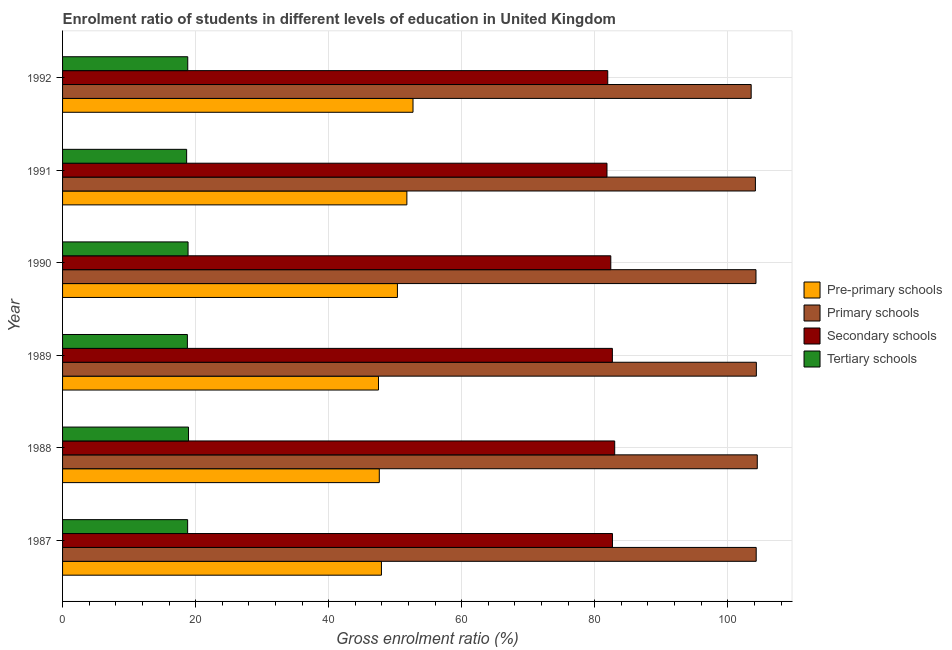How many different coloured bars are there?
Your answer should be compact. 4. How many groups of bars are there?
Your response must be concise. 6. Are the number of bars on each tick of the Y-axis equal?
Offer a terse response. Yes. How many bars are there on the 2nd tick from the top?
Provide a succinct answer. 4. How many bars are there on the 2nd tick from the bottom?
Your answer should be very brief. 4. What is the label of the 2nd group of bars from the top?
Your answer should be compact. 1991. In how many cases, is the number of bars for a given year not equal to the number of legend labels?
Keep it short and to the point. 0. What is the gross enrolment ratio in secondary schools in 1989?
Offer a very short reply. 82.65. Across all years, what is the maximum gross enrolment ratio in primary schools?
Offer a very short reply. 104.44. Across all years, what is the minimum gross enrolment ratio in pre-primary schools?
Make the answer very short. 47.49. In which year was the gross enrolment ratio in primary schools maximum?
Make the answer very short. 1988. In which year was the gross enrolment ratio in secondary schools minimum?
Make the answer very short. 1991. What is the total gross enrolment ratio in pre-primary schools in the graph?
Your response must be concise. 297.82. What is the difference between the gross enrolment ratio in tertiary schools in 1988 and that in 1989?
Provide a succinct answer. 0.17. What is the difference between the gross enrolment ratio in primary schools in 1987 and the gross enrolment ratio in tertiary schools in 1988?
Keep it short and to the point. 85.34. What is the average gross enrolment ratio in pre-primary schools per year?
Give a very brief answer. 49.64. In the year 1992, what is the difference between the gross enrolment ratio in pre-primary schools and gross enrolment ratio in tertiary schools?
Your answer should be compact. 33.86. In how many years, is the gross enrolment ratio in secondary schools greater than 96 %?
Keep it short and to the point. 0. What is the ratio of the gross enrolment ratio in tertiary schools in 1988 to that in 1990?
Keep it short and to the point. 1. Is the difference between the gross enrolment ratio in secondary schools in 1989 and 1990 greater than the difference between the gross enrolment ratio in tertiary schools in 1989 and 1990?
Your response must be concise. Yes. What is the difference between the highest and the second highest gross enrolment ratio in primary schools?
Give a very brief answer. 0.14. What is the difference between the highest and the lowest gross enrolment ratio in tertiary schools?
Offer a terse response. 0.28. In how many years, is the gross enrolment ratio in primary schools greater than the average gross enrolment ratio in primary schools taken over all years?
Offer a terse response. 5. Is the sum of the gross enrolment ratio in tertiary schools in 1989 and 1991 greater than the maximum gross enrolment ratio in pre-primary schools across all years?
Make the answer very short. No. What does the 4th bar from the top in 1991 represents?
Offer a very short reply. Pre-primary schools. What does the 1st bar from the bottom in 1992 represents?
Your answer should be very brief. Pre-primary schools. How many bars are there?
Ensure brevity in your answer.  24. Are all the bars in the graph horizontal?
Keep it short and to the point. Yes. What is the difference between two consecutive major ticks on the X-axis?
Provide a succinct answer. 20. What is the title of the graph?
Provide a succinct answer. Enrolment ratio of students in different levels of education in United Kingdom. Does "Source data assessment" appear as one of the legend labels in the graph?
Your answer should be compact. No. What is the label or title of the X-axis?
Offer a very short reply. Gross enrolment ratio (%). What is the Gross enrolment ratio (%) in Pre-primary schools in 1987?
Provide a succinct answer. 47.93. What is the Gross enrolment ratio (%) of Primary schools in 1987?
Your response must be concise. 104.27. What is the Gross enrolment ratio (%) of Secondary schools in 1987?
Your answer should be compact. 82.66. What is the Gross enrolment ratio (%) of Tertiary schools in 1987?
Offer a terse response. 18.8. What is the Gross enrolment ratio (%) of Pre-primary schools in 1988?
Keep it short and to the point. 47.61. What is the Gross enrolment ratio (%) of Primary schools in 1988?
Offer a very short reply. 104.44. What is the Gross enrolment ratio (%) of Secondary schools in 1988?
Your answer should be compact. 83. What is the Gross enrolment ratio (%) of Tertiary schools in 1988?
Offer a very short reply. 18.93. What is the Gross enrolment ratio (%) in Pre-primary schools in 1989?
Give a very brief answer. 47.49. What is the Gross enrolment ratio (%) of Primary schools in 1989?
Give a very brief answer. 104.29. What is the Gross enrolment ratio (%) of Secondary schools in 1989?
Offer a terse response. 82.65. What is the Gross enrolment ratio (%) in Tertiary schools in 1989?
Offer a very short reply. 18.76. What is the Gross enrolment ratio (%) of Pre-primary schools in 1990?
Offer a very short reply. 50.34. What is the Gross enrolment ratio (%) in Primary schools in 1990?
Make the answer very short. 104.24. What is the Gross enrolment ratio (%) of Secondary schools in 1990?
Provide a short and direct response. 82.41. What is the Gross enrolment ratio (%) of Tertiary schools in 1990?
Your answer should be very brief. 18.87. What is the Gross enrolment ratio (%) of Pre-primary schools in 1991?
Keep it short and to the point. 51.76. What is the Gross enrolment ratio (%) of Primary schools in 1991?
Offer a very short reply. 104.15. What is the Gross enrolment ratio (%) of Secondary schools in 1991?
Your answer should be compact. 81.84. What is the Gross enrolment ratio (%) in Tertiary schools in 1991?
Your response must be concise. 18.65. What is the Gross enrolment ratio (%) of Pre-primary schools in 1992?
Provide a short and direct response. 52.68. What is the Gross enrolment ratio (%) of Primary schools in 1992?
Provide a short and direct response. 103.52. What is the Gross enrolment ratio (%) in Secondary schools in 1992?
Your answer should be very brief. 81.96. What is the Gross enrolment ratio (%) of Tertiary schools in 1992?
Make the answer very short. 18.82. Across all years, what is the maximum Gross enrolment ratio (%) in Pre-primary schools?
Keep it short and to the point. 52.68. Across all years, what is the maximum Gross enrolment ratio (%) in Primary schools?
Offer a very short reply. 104.44. Across all years, what is the maximum Gross enrolment ratio (%) of Secondary schools?
Provide a short and direct response. 83. Across all years, what is the maximum Gross enrolment ratio (%) of Tertiary schools?
Your response must be concise. 18.93. Across all years, what is the minimum Gross enrolment ratio (%) in Pre-primary schools?
Keep it short and to the point. 47.49. Across all years, what is the minimum Gross enrolment ratio (%) in Primary schools?
Make the answer very short. 103.52. Across all years, what is the minimum Gross enrolment ratio (%) of Secondary schools?
Offer a terse response. 81.84. Across all years, what is the minimum Gross enrolment ratio (%) of Tertiary schools?
Keep it short and to the point. 18.65. What is the total Gross enrolment ratio (%) in Pre-primary schools in the graph?
Offer a terse response. 297.82. What is the total Gross enrolment ratio (%) in Primary schools in the graph?
Ensure brevity in your answer.  624.91. What is the total Gross enrolment ratio (%) of Secondary schools in the graph?
Your response must be concise. 494.53. What is the total Gross enrolment ratio (%) of Tertiary schools in the graph?
Ensure brevity in your answer.  112.84. What is the difference between the Gross enrolment ratio (%) of Pre-primary schools in 1987 and that in 1988?
Offer a very short reply. 0.32. What is the difference between the Gross enrolment ratio (%) in Primary schools in 1987 and that in 1988?
Provide a succinct answer. -0.16. What is the difference between the Gross enrolment ratio (%) of Secondary schools in 1987 and that in 1988?
Make the answer very short. -0.34. What is the difference between the Gross enrolment ratio (%) in Tertiary schools in 1987 and that in 1988?
Provide a succinct answer. -0.13. What is the difference between the Gross enrolment ratio (%) in Pre-primary schools in 1987 and that in 1989?
Provide a short and direct response. 0.44. What is the difference between the Gross enrolment ratio (%) of Primary schools in 1987 and that in 1989?
Provide a succinct answer. -0.02. What is the difference between the Gross enrolment ratio (%) in Secondary schools in 1987 and that in 1989?
Your answer should be very brief. 0.01. What is the difference between the Gross enrolment ratio (%) of Tertiary schools in 1987 and that in 1989?
Keep it short and to the point. 0.04. What is the difference between the Gross enrolment ratio (%) of Pre-primary schools in 1987 and that in 1990?
Your response must be concise. -2.4. What is the difference between the Gross enrolment ratio (%) in Primary schools in 1987 and that in 1990?
Provide a succinct answer. 0.03. What is the difference between the Gross enrolment ratio (%) in Secondary schools in 1987 and that in 1990?
Your answer should be very brief. 0.25. What is the difference between the Gross enrolment ratio (%) in Tertiary schools in 1987 and that in 1990?
Provide a succinct answer. -0.06. What is the difference between the Gross enrolment ratio (%) of Pre-primary schools in 1987 and that in 1991?
Your answer should be very brief. -3.82. What is the difference between the Gross enrolment ratio (%) in Primary schools in 1987 and that in 1991?
Your answer should be very brief. 0.12. What is the difference between the Gross enrolment ratio (%) in Secondary schools in 1987 and that in 1991?
Keep it short and to the point. 0.82. What is the difference between the Gross enrolment ratio (%) of Tertiary schools in 1987 and that in 1991?
Make the answer very short. 0.15. What is the difference between the Gross enrolment ratio (%) of Pre-primary schools in 1987 and that in 1992?
Your answer should be very brief. -4.75. What is the difference between the Gross enrolment ratio (%) in Primary schools in 1987 and that in 1992?
Your response must be concise. 0.76. What is the difference between the Gross enrolment ratio (%) of Secondary schools in 1987 and that in 1992?
Keep it short and to the point. 0.71. What is the difference between the Gross enrolment ratio (%) in Tertiary schools in 1987 and that in 1992?
Offer a terse response. -0.02. What is the difference between the Gross enrolment ratio (%) of Pre-primary schools in 1988 and that in 1989?
Ensure brevity in your answer.  0.12. What is the difference between the Gross enrolment ratio (%) of Primary schools in 1988 and that in 1989?
Offer a very short reply. 0.14. What is the difference between the Gross enrolment ratio (%) in Secondary schools in 1988 and that in 1989?
Ensure brevity in your answer.  0.35. What is the difference between the Gross enrolment ratio (%) in Tertiary schools in 1988 and that in 1989?
Your answer should be compact. 0.17. What is the difference between the Gross enrolment ratio (%) in Pre-primary schools in 1988 and that in 1990?
Offer a very short reply. -2.73. What is the difference between the Gross enrolment ratio (%) in Primary schools in 1988 and that in 1990?
Your answer should be compact. 0.2. What is the difference between the Gross enrolment ratio (%) of Secondary schools in 1988 and that in 1990?
Provide a succinct answer. 0.59. What is the difference between the Gross enrolment ratio (%) of Tertiary schools in 1988 and that in 1990?
Your answer should be very brief. 0.07. What is the difference between the Gross enrolment ratio (%) of Pre-primary schools in 1988 and that in 1991?
Give a very brief answer. -4.14. What is the difference between the Gross enrolment ratio (%) of Primary schools in 1988 and that in 1991?
Ensure brevity in your answer.  0.28. What is the difference between the Gross enrolment ratio (%) of Secondary schools in 1988 and that in 1991?
Ensure brevity in your answer.  1.16. What is the difference between the Gross enrolment ratio (%) of Tertiary schools in 1988 and that in 1991?
Your answer should be very brief. 0.28. What is the difference between the Gross enrolment ratio (%) of Pre-primary schools in 1988 and that in 1992?
Provide a succinct answer. -5.07. What is the difference between the Gross enrolment ratio (%) of Primary schools in 1988 and that in 1992?
Offer a terse response. 0.92. What is the difference between the Gross enrolment ratio (%) in Secondary schools in 1988 and that in 1992?
Ensure brevity in your answer.  1.05. What is the difference between the Gross enrolment ratio (%) of Tertiary schools in 1988 and that in 1992?
Provide a short and direct response. 0.12. What is the difference between the Gross enrolment ratio (%) in Pre-primary schools in 1989 and that in 1990?
Your response must be concise. -2.84. What is the difference between the Gross enrolment ratio (%) in Primary schools in 1989 and that in 1990?
Your response must be concise. 0.06. What is the difference between the Gross enrolment ratio (%) in Secondary schools in 1989 and that in 1990?
Your response must be concise. 0.24. What is the difference between the Gross enrolment ratio (%) in Tertiary schools in 1989 and that in 1990?
Offer a very short reply. -0.1. What is the difference between the Gross enrolment ratio (%) in Pre-primary schools in 1989 and that in 1991?
Ensure brevity in your answer.  -4.26. What is the difference between the Gross enrolment ratio (%) in Primary schools in 1989 and that in 1991?
Provide a short and direct response. 0.14. What is the difference between the Gross enrolment ratio (%) of Secondary schools in 1989 and that in 1991?
Provide a short and direct response. 0.81. What is the difference between the Gross enrolment ratio (%) of Tertiary schools in 1989 and that in 1991?
Your answer should be compact. 0.11. What is the difference between the Gross enrolment ratio (%) in Pre-primary schools in 1989 and that in 1992?
Make the answer very short. -5.19. What is the difference between the Gross enrolment ratio (%) of Primary schools in 1989 and that in 1992?
Offer a very short reply. 0.78. What is the difference between the Gross enrolment ratio (%) in Secondary schools in 1989 and that in 1992?
Offer a terse response. 0.7. What is the difference between the Gross enrolment ratio (%) in Tertiary schools in 1989 and that in 1992?
Ensure brevity in your answer.  -0.05. What is the difference between the Gross enrolment ratio (%) of Pre-primary schools in 1990 and that in 1991?
Your answer should be very brief. -1.42. What is the difference between the Gross enrolment ratio (%) of Primary schools in 1990 and that in 1991?
Ensure brevity in your answer.  0.09. What is the difference between the Gross enrolment ratio (%) in Secondary schools in 1990 and that in 1991?
Keep it short and to the point. 0.57. What is the difference between the Gross enrolment ratio (%) in Tertiary schools in 1990 and that in 1991?
Offer a terse response. 0.21. What is the difference between the Gross enrolment ratio (%) in Pre-primary schools in 1990 and that in 1992?
Offer a terse response. -2.34. What is the difference between the Gross enrolment ratio (%) of Primary schools in 1990 and that in 1992?
Your response must be concise. 0.72. What is the difference between the Gross enrolment ratio (%) of Secondary schools in 1990 and that in 1992?
Your response must be concise. 0.46. What is the difference between the Gross enrolment ratio (%) in Tertiary schools in 1990 and that in 1992?
Your answer should be compact. 0.05. What is the difference between the Gross enrolment ratio (%) of Pre-primary schools in 1991 and that in 1992?
Offer a very short reply. -0.92. What is the difference between the Gross enrolment ratio (%) in Primary schools in 1991 and that in 1992?
Keep it short and to the point. 0.64. What is the difference between the Gross enrolment ratio (%) of Secondary schools in 1991 and that in 1992?
Give a very brief answer. -0.11. What is the difference between the Gross enrolment ratio (%) in Tertiary schools in 1991 and that in 1992?
Your response must be concise. -0.17. What is the difference between the Gross enrolment ratio (%) of Pre-primary schools in 1987 and the Gross enrolment ratio (%) of Primary schools in 1988?
Provide a short and direct response. -56.5. What is the difference between the Gross enrolment ratio (%) in Pre-primary schools in 1987 and the Gross enrolment ratio (%) in Secondary schools in 1988?
Offer a very short reply. -35.07. What is the difference between the Gross enrolment ratio (%) in Pre-primary schools in 1987 and the Gross enrolment ratio (%) in Tertiary schools in 1988?
Provide a succinct answer. 29. What is the difference between the Gross enrolment ratio (%) of Primary schools in 1987 and the Gross enrolment ratio (%) of Secondary schools in 1988?
Keep it short and to the point. 21.27. What is the difference between the Gross enrolment ratio (%) in Primary schools in 1987 and the Gross enrolment ratio (%) in Tertiary schools in 1988?
Provide a succinct answer. 85.34. What is the difference between the Gross enrolment ratio (%) of Secondary schools in 1987 and the Gross enrolment ratio (%) of Tertiary schools in 1988?
Your response must be concise. 63.73. What is the difference between the Gross enrolment ratio (%) of Pre-primary schools in 1987 and the Gross enrolment ratio (%) of Primary schools in 1989?
Your answer should be very brief. -56.36. What is the difference between the Gross enrolment ratio (%) in Pre-primary schools in 1987 and the Gross enrolment ratio (%) in Secondary schools in 1989?
Provide a succinct answer. -34.72. What is the difference between the Gross enrolment ratio (%) of Pre-primary schools in 1987 and the Gross enrolment ratio (%) of Tertiary schools in 1989?
Provide a short and direct response. 29.17. What is the difference between the Gross enrolment ratio (%) in Primary schools in 1987 and the Gross enrolment ratio (%) in Secondary schools in 1989?
Your answer should be compact. 21.62. What is the difference between the Gross enrolment ratio (%) of Primary schools in 1987 and the Gross enrolment ratio (%) of Tertiary schools in 1989?
Make the answer very short. 85.51. What is the difference between the Gross enrolment ratio (%) in Secondary schools in 1987 and the Gross enrolment ratio (%) in Tertiary schools in 1989?
Offer a terse response. 63.9. What is the difference between the Gross enrolment ratio (%) of Pre-primary schools in 1987 and the Gross enrolment ratio (%) of Primary schools in 1990?
Offer a terse response. -56.3. What is the difference between the Gross enrolment ratio (%) of Pre-primary schools in 1987 and the Gross enrolment ratio (%) of Secondary schools in 1990?
Keep it short and to the point. -34.48. What is the difference between the Gross enrolment ratio (%) in Pre-primary schools in 1987 and the Gross enrolment ratio (%) in Tertiary schools in 1990?
Provide a short and direct response. 29.07. What is the difference between the Gross enrolment ratio (%) of Primary schools in 1987 and the Gross enrolment ratio (%) of Secondary schools in 1990?
Offer a terse response. 21.86. What is the difference between the Gross enrolment ratio (%) of Primary schools in 1987 and the Gross enrolment ratio (%) of Tertiary schools in 1990?
Keep it short and to the point. 85.41. What is the difference between the Gross enrolment ratio (%) in Secondary schools in 1987 and the Gross enrolment ratio (%) in Tertiary schools in 1990?
Offer a terse response. 63.8. What is the difference between the Gross enrolment ratio (%) in Pre-primary schools in 1987 and the Gross enrolment ratio (%) in Primary schools in 1991?
Offer a terse response. -56.22. What is the difference between the Gross enrolment ratio (%) in Pre-primary schools in 1987 and the Gross enrolment ratio (%) in Secondary schools in 1991?
Your response must be concise. -33.91. What is the difference between the Gross enrolment ratio (%) of Pre-primary schools in 1987 and the Gross enrolment ratio (%) of Tertiary schools in 1991?
Make the answer very short. 29.28. What is the difference between the Gross enrolment ratio (%) of Primary schools in 1987 and the Gross enrolment ratio (%) of Secondary schools in 1991?
Provide a short and direct response. 22.43. What is the difference between the Gross enrolment ratio (%) in Primary schools in 1987 and the Gross enrolment ratio (%) in Tertiary schools in 1991?
Give a very brief answer. 85.62. What is the difference between the Gross enrolment ratio (%) in Secondary schools in 1987 and the Gross enrolment ratio (%) in Tertiary schools in 1991?
Offer a very short reply. 64.01. What is the difference between the Gross enrolment ratio (%) of Pre-primary schools in 1987 and the Gross enrolment ratio (%) of Primary schools in 1992?
Ensure brevity in your answer.  -55.58. What is the difference between the Gross enrolment ratio (%) of Pre-primary schools in 1987 and the Gross enrolment ratio (%) of Secondary schools in 1992?
Make the answer very short. -34.02. What is the difference between the Gross enrolment ratio (%) in Pre-primary schools in 1987 and the Gross enrolment ratio (%) in Tertiary schools in 1992?
Keep it short and to the point. 29.12. What is the difference between the Gross enrolment ratio (%) of Primary schools in 1987 and the Gross enrolment ratio (%) of Secondary schools in 1992?
Provide a short and direct response. 22.32. What is the difference between the Gross enrolment ratio (%) of Primary schools in 1987 and the Gross enrolment ratio (%) of Tertiary schools in 1992?
Keep it short and to the point. 85.45. What is the difference between the Gross enrolment ratio (%) of Secondary schools in 1987 and the Gross enrolment ratio (%) of Tertiary schools in 1992?
Your answer should be compact. 63.85. What is the difference between the Gross enrolment ratio (%) in Pre-primary schools in 1988 and the Gross enrolment ratio (%) in Primary schools in 1989?
Ensure brevity in your answer.  -56.68. What is the difference between the Gross enrolment ratio (%) in Pre-primary schools in 1988 and the Gross enrolment ratio (%) in Secondary schools in 1989?
Offer a very short reply. -35.04. What is the difference between the Gross enrolment ratio (%) in Pre-primary schools in 1988 and the Gross enrolment ratio (%) in Tertiary schools in 1989?
Offer a very short reply. 28.85. What is the difference between the Gross enrolment ratio (%) in Primary schools in 1988 and the Gross enrolment ratio (%) in Secondary schools in 1989?
Provide a succinct answer. 21.78. What is the difference between the Gross enrolment ratio (%) in Primary schools in 1988 and the Gross enrolment ratio (%) in Tertiary schools in 1989?
Your answer should be very brief. 85.67. What is the difference between the Gross enrolment ratio (%) of Secondary schools in 1988 and the Gross enrolment ratio (%) of Tertiary schools in 1989?
Keep it short and to the point. 64.24. What is the difference between the Gross enrolment ratio (%) in Pre-primary schools in 1988 and the Gross enrolment ratio (%) in Primary schools in 1990?
Provide a succinct answer. -56.63. What is the difference between the Gross enrolment ratio (%) in Pre-primary schools in 1988 and the Gross enrolment ratio (%) in Secondary schools in 1990?
Ensure brevity in your answer.  -34.8. What is the difference between the Gross enrolment ratio (%) in Pre-primary schools in 1988 and the Gross enrolment ratio (%) in Tertiary schools in 1990?
Your response must be concise. 28.75. What is the difference between the Gross enrolment ratio (%) of Primary schools in 1988 and the Gross enrolment ratio (%) of Secondary schools in 1990?
Make the answer very short. 22.02. What is the difference between the Gross enrolment ratio (%) of Primary schools in 1988 and the Gross enrolment ratio (%) of Tertiary schools in 1990?
Give a very brief answer. 85.57. What is the difference between the Gross enrolment ratio (%) of Secondary schools in 1988 and the Gross enrolment ratio (%) of Tertiary schools in 1990?
Ensure brevity in your answer.  64.14. What is the difference between the Gross enrolment ratio (%) of Pre-primary schools in 1988 and the Gross enrolment ratio (%) of Primary schools in 1991?
Offer a very short reply. -56.54. What is the difference between the Gross enrolment ratio (%) in Pre-primary schools in 1988 and the Gross enrolment ratio (%) in Secondary schools in 1991?
Offer a very short reply. -34.23. What is the difference between the Gross enrolment ratio (%) in Pre-primary schools in 1988 and the Gross enrolment ratio (%) in Tertiary schools in 1991?
Give a very brief answer. 28.96. What is the difference between the Gross enrolment ratio (%) in Primary schools in 1988 and the Gross enrolment ratio (%) in Secondary schools in 1991?
Your answer should be very brief. 22.59. What is the difference between the Gross enrolment ratio (%) in Primary schools in 1988 and the Gross enrolment ratio (%) in Tertiary schools in 1991?
Your answer should be very brief. 85.78. What is the difference between the Gross enrolment ratio (%) in Secondary schools in 1988 and the Gross enrolment ratio (%) in Tertiary schools in 1991?
Offer a very short reply. 64.35. What is the difference between the Gross enrolment ratio (%) of Pre-primary schools in 1988 and the Gross enrolment ratio (%) of Primary schools in 1992?
Provide a short and direct response. -55.9. What is the difference between the Gross enrolment ratio (%) of Pre-primary schools in 1988 and the Gross enrolment ratio (%) of Secondary schools in 1992?
Give a very brief answer. -34.34. What is the difference between the Gross enrolment ratio (%) in Pre-primary schools in 1988 and the Gross enrolment ratio (%) in Tertiary schools in 1992?
Your response must be concise. 28.8. What is the difference between the Gross enrolment ratio (%) of Primary schools in 1988 and the Gross enrolment ratio (%) of Secondary schools in 1992?
Make the answer very short. 22.48. What is the difference between the Gross enrolment ratio (%) in Primary schools in 1988 and the Gross enrolment ratio (%) in Tertiary schools in 1992?
Provide a short and direct response. 85.62. What is the difference between the Gross enrolment ratio (%) in Secondary schools in 1988 and the Gross enrolment ratio (%) in Tertiary schools in 1992?
Provide a succinct answer. 64.18. What is the difference between the Gross enrolment ratio (%) of Pre-primary schools in 1989 and the Gross enrolment ratio (%) of Primary schools in 1990?
Keep it short and to the point. -56.74. What is the difference between the Gross enrolment ratio (%) in Pre-primary schools in 1989 and the Gross enrolment ratio (%) in Secondary schools in 1990?
Your answer should be very brief. -34.92. What is the difference between the Gross enrolment ratio (%) of Pre-primary schools in 1989 and the Gross enrolment ratio (%) of Tertiary schools in 1990?
Give a very brief answer. 28.63. What is the difference between the Gross enrolment ratio (%) in Primary schools in 1989 and the Gross enrolment ratio (%) in Secondary schools in 1990?
Your response must be concise. 21.88. What is the difference between the Gross enrolment ratio (%) of Primary schools in 1989 and the Gross enrolment ratio (%) of Tertiary schools in 1990?
Provide a succinct answer. 85.43. What is the difference between the Gross enrolment ratio (%) of Secondary schools in 1989 and the Gross enrolment ratio (%) of Tertiary schools in 1990?
Ensure brevity in your answer.  63.79. What is the difference between the Gross enrolment ratio (%) in Pre-primary schools in 1989 and the Gross enrolment ratio (%) in Primary schools in 1991?
Offer a terse response. -56.66. What is the difference between the Gross enrolment ratio (%) of Pre-primary schools in 1989 and the Gross enrolment ratio (%) of Secondary schools in 1991?
Your answer should be compact. -34.35. What is the difference between the Gross enrolment ratio (%) of Pre-primary schools in 1989 and the Gross enrolment ratio (%) of Tertiary schools in 1991?
Your response must be concise. 28.84. What is the difference between the Gross enrolment ratio (%) in Primary schools in 1989 and the Gross enrolment ratio (%) in Secondary schools in 1991?
Provide a succinct answer. 22.45. What is the difference between the Gross enrolment ratio (%) in Primary schools in 1989 and the Gross enrolment ratio (%) in Tertiary schools in 1991?
Your answer should be very brief. 85.64. What is the difference between the Gross enrolment ratio (%) of Secondary schools in 1989 and the Gross enrolment ratio (%) of Tertiary schools in 1991?
Your answer should be very brief. 64. What is the difference between the Gross enrolment ratio (%) of Pre-primary schools in 1989 and the Gross enrolment ratio (%) of Primary schools in 1992?
Offer a terse response. -56.02. What is the difference between the Gross enrolment ratio (%) in Pre-primary schools in 1989 and the Gross enrolment ratio (%) in Secondary schools in 1992?
Keep it short and to the point. -34.46. What is the difference between the Gross enrolment ratio (%) in Pre-primary schools in 1989 and the Gross enrolment ratio (%) in Tertiary schools in 1992?
Ensure brevity in your answer.  28.68. What is the difference between the Gross enrolment ratio (%) of Primary schools in 1989 and the Gross enrolment ratio (%) of Secondary schools in 1992?
Your answer should be very brief. 22.34. What is the difference between the Gross enrolment ratio (%) in Primary schools in 1989 and the Gross enrolment ratio (%) in Tertiary schools in 1992?
Your response must be concise. 85.48. What is the difference between the Gross enrolment ratio (%) of Secondary schools in 1989 and the Gross enrolment ratio (%) of Tertiary schools in 1992?
Make the answer very short. 63.83. What is the difference between the Gross enrolment ratio (%) of Pre-primary schools in 1990 and the Gross enrolment ratio (%) of Primary schools in 1991?
Ensure brevity in your answer.  -53.81. What is the difference between the Gross enrolment ratio (%) of Pre-primary schools in 1990 and the Gross enrolment ratio (%) of Secondary schools in 1991?
Your response must be concise. -31.5. What is the difference between the Gross enrolment ratio (%) of Pre-primary schools in 1990 and the Gross enrolment ratio (%) of Tertiary schools in 1991?
Provide a succinct answer. 31.69. What is the difference between the Gross enrolment ratio (%) in Primary schools in 1990 and the Gross enrolment ratio (%) in Secondary schools in 1991?
Offer a very short reply. 22.4. What is the difference between the Gross enrolment ratio (%) of Primary schools in 1990 and the Gross enrolment ratio (%) of Tertiary schools in 1991?
Make the answer very short. 85.59. What is the difference between the Gross enrolment ratio (%) of Secondary schools in 1990 and the Gross enrolment ratio (%) of Tertiary schools in 1991?
Offer a terse response. 63.76. What is the difference between the Gross enrolment ratio (%) of Pre-primary schools in 1990 and the Gross enrolment ratio (%) of Primary schools in 1992?
Give a very brief answer. -53.18. What is the difference between the Gross enrolment ratio (%) in Pre-primary schools in 1990 and the Gross enrolment ratio (%) in Secondary schools in 1992?
Provide a short and direct response. -31.62. What is the difference between the Gross enrolment ratio (%) of Pre-primary schools in 1990 and the Gross enrolment ratio (%) of Tertiary schools in 1992?
Give a very brief answer. 31.52. What is the difference between the Gross enrolment ratio (%) in Primary schools in 1990 and the Gross enrolment ratio (%) in Secondary schools in 1992?
Offer a very short reply. 22.28. What is the difference between the Gross enrolment ratio (%) in Primary schools in 1990 and the Gross enrolment ratio (%) in Tertiary schools in 1992?
Offer a terse response. 85.42. What is the difference between the Gross enrolment ratio (%) in Secondary schools in 1990 and the Gross enrolment ratio (%) in Tertiary schools in 1992?
Give a very brief answer. 63.6. What is the difference between the Gross enrolment ratio (%) in Pre-primary schools in 1991 and the Gross enrolment ratio (%) in Primary schools in 1992?
Ensure brevity in your answer.  -51.76. What is the difference between the Gross enrolment ratio (%) of Pre-primary schools in 1991 and the Gross enrolment ratio (%) of Secondary schools in 1992?
Ensure brevity in your answer.  -30.2. What is the difference between the Gross enrolment ratio (%) in Pre-primary schools in 1991 and the Gross enrolment ratio (%) in Tertiary schools in 1992?
Your answer should be very brief. 32.94. What is the difference between the Gross enrolment ratio (%) of Primary schools in 1991 and the Gross enrolment ratio (%) of Secondary schools in 1992?
Ensure brevity in your answer.  22.2. What is the difference between the Gross enrolment ratio (%) in Primary schools in 1991 and the Gross enrolment ratio (%) in Tertiary schools in 1992?
Provide a short and direct response. 85.33. What is the difference between the Gross enrolment ratio (%) of Secondary schools in 1991 and the Gross enrolment ratio (%) of Tertiary schools in 1992?
Your answer should be compact. 63.02. What is the average Gross enrolment ratio (%) in Pre-primary schools per year?
Offer a very short reply. 49.64. What is the average Gross enrolment ratio (%) of Primary schools per year?
Provide a short and direct response. 104.15. What is the average Gross enrolment ratio (%) in Secondary schools per year?
Keep it short and to the point. 82.42. What is the average Gross enrolment ratio (%) of Tertiary schools per year?
Ensure brevity in your answer.  18.81. In the year 1987, what is the difference between the Gross enrolment ratio (%) of Pre-primary schools and Gross enrolment ratio (%) of Primary schools?
Your answer should be very brief. -56.34. In the year 1987, what is the difference between the Gross enrolment ratio (%) in Pre-primary schools and Gross enrolment ratio (%) in Secondary schools?
Make the answer very short. -34.73. In the year 1987, what is the difference between the Gross enrolment ratio (%) of Pre-primary schools and Gross enrolment ratio (%) of Tertiary schools?
Your answer should be very brief. 29.13. In the year 1987, what is the difference between the Gross enrolment ratio (%) of Primary schools and Gross enrolment ratio (%) of Secondary schools?
Your answer should be very brief. 21.61. In the year 1987, what is the difference between the Gross enrolment ratio (%) of Primary schools and Gross enrolment ratio (%) of Tertiary schools?
Ensure brevity in your answer.  85.47. In the year 1987, what is the difference between the Gross enrolment ratio (%) of Secondary schools and Gross enrolment ratio (%) of Tertiary schools?
Keep it short and to the point. 63.86. In the year 1988, what is the difference between the Gross enrolment ratio (%) of Pre-primary schools and Gross enrolment ratio (%) of Primary schools?
Your answer should be compact. -56.82. In the year 1988, what is the difference between the Gross enrolment ratio (%) in Pre-primary schools and Gross enrolment ratio (%) in Secondary schools?
Your response must be concise. -35.39. In the year 1988, what is the difference between the Gross enrolment ratio (%) of Pre-primary schools and Gross enrolment ratio (%) of Tertiary schools?
Give a very brief answer. 28.68. In the year 1988, what is the difference between the Gross enrolment ratio (%) in Primary schools and Gross enrolment ratio (%) in Secondary schools?
Offer a very short reply. 21.43. In the year 1988, what is the difference between the Gross enrolment ratio (%) in Primary schools and Gross enrolment ratio (%) in Tertiary schools?
Offer a terse response. 85.5. In the year 1988, what is the difference between the Gross enrolment ratio (%) in Secondary schools and Gross enrolment ratio (%) in Tertiary schools?
Your response must be concise. 64.07. In the year 1989, what is the difference between the Gross enrolment ratio (%) in Pre-primary schools and Gross enrolment ratio (%) in Primary schools?
Provide a succinct answer. -56.8. In the year 1989, what is the difference between the Gross enrolment ratio (%) of Pre-primary schools and Gross enrolment ratio (%) of Secondary schools?
Offer a terse response. -35.16. In the year 1989, what is the difference between the Gross enrolment ratio (%) of Pre-primary schools and Gross enrolment ratio (%) of Tertiary schools?
Give a very brief answer. 28.73. In the year 1989, what is the difference between the Gross enrolment ratio (%) of Primary schools and Gross enrolment ratio (%) of Secondary schools?
Your answer should be very brief. 21.64. In the year 1989, what is the difference between the Gross enrolment ratio (%) of Primary schools and Gross enrolment ratio (%) of Tertiary schools?
Offer a very short reply. 85.53. In the year 1989, what is the difference between the Gross enrolment ratio (%) of Secondary schools and Gross enrolment ratio (%) of Tertiary schools?
Give a very brief answer. 63.89. In the year 1990, what is the difference between the Gross enrolment ratio (%) in Pre-primary schools and Gross enrolment ratio (%) in Primary schools?
Give a very brief answer. -53.9. In the year 1990, what is the difference between the Gross enrolment ratio (%) of Pre-primary schools and Gross enrolment ratio (%) of Secondary schools?
Provide a succinct answer. -32.08. In the year 1990, what is the difference between the Gross enrolment ratio (%) of Pre-primary schools and Gross enrolment ratio (%) of Tertiary schools?
Keep it short and to the point. 31.47. In the year 1990, what is the difference between the Gross enrolment ratio (%) in Primary schools and Gross enrolment ratio (%) in Secondary schools?
Offer a very short reply. 21.82. In the year 1990, what is the difference between the Gross enrolment ratio (%) in Primary schools and Gross enrolment ratio (%) in Tertiary schools?
Offer a terse response. 85.37. In the year 1990, what is the difference between the Gross enrolment ratio (%) in Secondary schools and Gross enrolment ratio (%) in Tertiary schools?
Make the answer very short. 63.55. In the year 1991, what is the difference between the Gross enrolment ratio (%) in Pre-primary schools and Gross enrolment ratio (%) in Primary schools?
Offer a terse response. -52.39. In the year 1991, what is the difference between the Gross enrolment ratio (%) of Pre-primary schools and Gross enrolment ratio (%) of Secondary schools?
Offer a very short reply. -30.08. In the year 1991, what is the difference between the Gross enrolment ratio (%) in Pre-primary schools and Gross enrolment ratio (%) in Tertiary schools?
Offer a very short reply. 33.11. In the year 1991, what is the difference between the Gross enrolment ratio (%) of Primary schools and Gross enrolment ratio (%) of Secondary schools?
Offer a terse response. 22.31. In the year 1991, what is the difference between the Gross enrolment ratio (%) of Primary schools and Gross enrolment ratio (%) of Tertiary schools?
Make the answer very short. 85.5. In the year 1991, what is the difference between the Gross enrolment ratio (%) in Secondary schools and Gross enrolment ratio (%) in Tertiary schools?
Give a very brief answer. 63.19. In the year 1992, what is the difference between the Gross enrolment ratio (%) in Pre-primary schools and Gross enrolment ratio (%) in Primary schools?
Ensure brevity in your answer.  -50.83. In the year 1992, what is the difference between the Gross enrolment ratio (%) in Pre-primary schools and Gross enrolment ratio (%) in Secondary schools?
Keep it short and to the point. -29.27. In the year 1992, what is the difference between the Gross enrolment ratio (%) of Pre-primary schools and Gross enrolment ratio (%) of Tertiary schools?
Your answer should be compact. 33.86. In the year 1992, what is the difference between the Gross enrolment ratio (%) in Primary schools and Gross enrolment ratio (%) in Secondary schools?
Your response must be concise. 21.56. In the year 1992, what is the difference between the Gross enrolment ratio (%) of Primary schools and Gross enrolment ratio (%) of Tertiary schools?
Offer a terse response. 84.7. In the year 1992, what is the difference between the Gross enrolment ratio (%) of Secondary schools and Gross enrolment ratio (%) of Tertiary schools?
Keep it short and to the point. 63.14. What is the ratio of the Gross enrolment ratio (%) in Pre-primary schools in 1987 to that in 1988?
Your answer should be compact. 1.01. What is the ratio of the Gross enrolment ratio (%) in Primary schools in 1987 to that in 1988?
Give a very brief answer. 1. What is the ratio of the Gross enrolment ratio (%) in Pre-primary schools in 1987 to that in 1989?
Offer a terse response. 1.01. What is the ratio of the Gross enrolment ratio (%) in Primary schools in 1987 to that in 1989?
Provide a succinct answer. 1. What is the ratio of the Gross enrolment ratio (%) in Secondary schools in 1987 to that in 1989?
Ensure brevity in your answer.  1. What is the ratio of the Gross enrolment ratio (%) in Pre-primary schools in 1987 to that in 1990?
Your answer should be compact. 0.95. What is the ratio of the Gross enrolment ratio (%) in Pre-primary schools in 1987 to that in 1991?
Your response must be concise. 0.93. What is the ratio of the Gross enrolment ratio (%) in Primary schools in 1987 to that in 1991?
Keep it short and to the point. 1. What is the ratio of the Gross enrolment ratio (%) of Pre-primary schools in 1987 to that in 1992?
Keep it short and to the point. 0.91. What is the ratio of the Gross enrolment ratio (%) in Primary schools in 1987 to that in 1992?
Make the answer very short. 1.01. What is the ratio of the Gross enrolment ratio (%) of Secondary schools in 1987 to that in 1992?
Ensure brevity in your answer.  1.01. What is the ratio of the Gross enrolment ratio (%) of Tertiary schools in 1987 to that in 1992?
Provide a short and direct response. 1. What is the ratio of the Gross enrolment ratio (%) in Pre-primary schools in 1988 to that in 1989?
Make the answer very short. 1. What is the ratio of the Gross enrolment ratio (%) in Primary schools in 1988 to that in 1989?
Make the answer very short. 1. What is the ratio of the Gross enrolment ratio (%) of Secondary schools in 1988 to that in 1989?
Your answer should be very brief. 1. What is the ratio of the Gross enrolment ratio (%) in Tertiary schools in 1988 to that in 1989?
Your response must be concise. 1.01. What is the ratio of the Gross enrolment ratio (%) of Pre-primary schools in 1988 to that in 1990?
Your answer should be very brief. 0.95. What is the ratio of the Gross enrolment ratio (%) in Secondary schools in 1988 to that in 1990?
Ensure brevity in your answer.  1.01. What is the ratio of the Gross enrolment ratio (%) in Pre-primary schools in 1988 to that in 1991?
Offer a very short reply. 0.92. What is the ratio of the Gross enrolment ratio (%) of Secondary schools in 1988 to that in 1991?
Your response must be concise. 1.01. What is the ratio of the Gross enrolment ratio (%) in Tertiary schools in 1988 to that in 1991?
Ensure brevity in your answer.  1.02. What is the ratio of the Gross enrolment ratio (%) of Pre-primary schools in 1988 to that in 1992?
Ensure brevity in your answer.  0.9. What is the ratio of the Gross enrolment ratio (%) of Primary schools in 1988 to that in 1992?
Keep it short and to the point. 1.01. What is the ratio of the Gross enrolment ratio (%) in Secondary schools in 1988 to that in 1992?
Ensure brevity in your answer.  1.01. What is the ratio of the Gross enrolment ratio (%) of Tertiary schools in 1988 to that in 1992?
Offer a very short reply. 1.01. What is the ratio of the Gross enrolment ratio (%) in Pre-primary schools in 1989 to that in 1990?
Your answer should be very brief. 0.94. What is the ratio of the Gross enrolment ratio (%) of Primary schools in 1989 to that in 1990?
Offer a very short reply. 1. What is the ratio of the Gross enrolment ratio (%) in Pre-primary schools in 1989 to that in 1991?
Offer a very short reply. 0.92. What is the ratio of the Gross enrolment ratio (%) of Primary schools in 1989 to that in 1991?
Provide a succinct answer. 1. What is the ratio of the Gross enrolment ratio (%) of Secondary schools in 1989 to that in 1991?
Your answer should be compact. 1.01. What is the ratio of the Gross enrolment ratio (%) of Tertiary schools in 1989 to that in 1991?
Provide a short and direct response. 1.01. What is the ratio of the Gross enrolment ratio (%) of Pre-primary schools in 1989 to that in 1992?
Give a very brief answer. 0.9. What is the ratio of the Gross enrolment ratio (%) of Primary schools in 1989 to that in 1992?
Your answer should be very brief. 1.01. What is the ratio of the Gross enrolment ratio (%) of Secondary schools in 1989 to that in 1992?
Keep it short and to the point. 1.01. What is the ratio of the Gross enrolment ratio (%) of Tertiary schools in 1989 to that in 1992?
Keep it short and to the point. 1. What is the ratio of the Gross enrolment ratio (%) of Pre-primary schools in 1990 to that in 1991?
Provide a short and direct response. 0.97. What is the ratio of the Gross enrolment ratio (%) in Primary schools in 1990 to that in 1991?
Offer a very short reply. 1. What is the ratio of the Gross enrolment ratio (%) of Secondary schools in 1990 to that in 1991?
Your answer should be compact. 1.01. What is the ratio of the Gross enrolment ratio (%) in Tertiary schools in 1990 to that in 1991?
Provide a short and direct response. 1.01. What is the ratio of the Gross enrolment ratio (%) in Pre-primary schools in 1990 to that in 1992?
Provide a succinct answer. 0.96. What is the ratio of the Gross enrolment ratio (%) in Primary schools in 1990 to that in 1992?
Give a very brief answer. 1.01. What is the ratio of the Gross enrolment ratio (%) in Secondary schools in 1990 to that in 1992?
Keep it short and to the point. 1.01. What is the ratio of the Gross enrolment ratio (%) of Pre-primary schools in 1991 to that in 1992?
Your answer should be compact. 0.98. What is the ratio of the Gross enrolment ratio (%) of Primary schools in 1991 to that in 1992?
Make the answer very short. 1.01. What is the ratio of the Gross enrolment ratio (%) of Secondary schools in 1991 to that in 1992?
Offer a very short reply. 1. What is the difference between the highest and the second highest Gross enrolment ratio (%) in Pre-primary schools?
Keep it short and to the point. 0.92. What is the difference between the highest and the second highest Gross enrolment ratio (%) in Primary schools?
Give a very brief answer. 0.14. What is the difference between the highest and the second highest Gross enrolment ratio (%) in Secondary schools?
Make the answer very short. 0.34. What is the difference between the highest and the second highest Gross enrolment ratio (%) in Tertiary schools?
Give a very brief answer. 0.07. What is the difference between the highest and the lowest Gross enrolment ratio (%) of Pre-primary schools?
Give a very brief answer. 5.19. What is the difference between the highest and the lowest Gross enrolment ratio (%) in Primary schools?
Your answer should be compact. 0.92. What is the difference between the highest and the lowest Gross enrolment ratio (%) of Secondary schools?
Offer a very short reply. 1.16. What is the difference between the highest and the lowest Gross enrolment ratio (%) of Tertiary schools?
Your answer should be very brief. 0.28. 